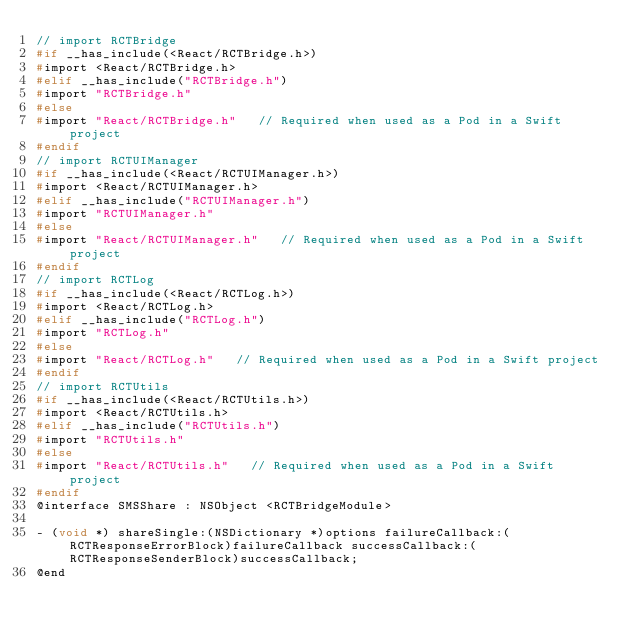Convert code to text. <code><loc_0><loc_0><loc_500><loc_500><_C_>// import RCTBridge
#if __has_include(<React/RCTBridge.h>)
#import <React/RCTBridge.h>
#elif __has_include("RCTBridge.h")
#import "RCTBridge.h"
#else
#import "React/RCTBridge.h"   // Required when used as a Pod in a Swift project
#endif
// import RCTUIManager
#if __has_include(<React/RCTUIManager.h>)
#import <React/RCTUIManager.h>
#elif __has_include("RCTUIManager.h")
#import "RCTUIManager.h"
#else
#import "React/RCTUIManager.h"   // Required when used as a Pod in a Swift project
#endif
// import RCTLog
#if __has_include(<React/RCTLog.h>)
#import <React/RCTLog.h>
#elif __has_include("RCTLog.h")
#import "RCTLog.h"
#else
#import "React/RCTLog.h"   // Required when used as a Pod in a Swift project
#endif
// import RCTUtils
#if __has_include(<React/RCTUtils.h>)
#import <React/RCTUtils.h>
#elif __has_include("RCTUtils.h")
#import "RCTUtils.h"
#else
#import "React/RCTUtils.h"   // Required when used as a Pod in a Swift project
#endif
@interface SMSShare : NSObject <RCTBridgeModule>

- (void *) shareSingle:(NSDictionary *)options failureCallback:(RCTResponseErrorBlock)failureCallback successCallback:(RCTResponseSenderBlock)successCallback;
@end
</code> 